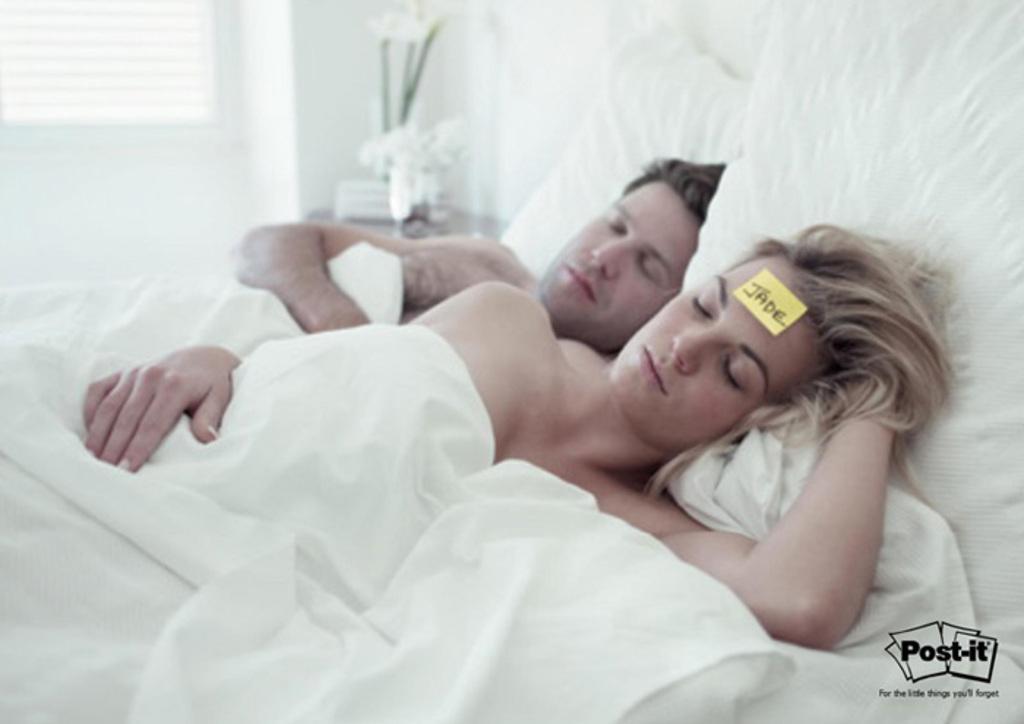Describe this image in one or two sentences. In this image on a lady and a man are sleeping. On a paper Jade is written which is stick to lady`s head. There is a side table beside the bed on the table there are flowers. There is a window in the background. 